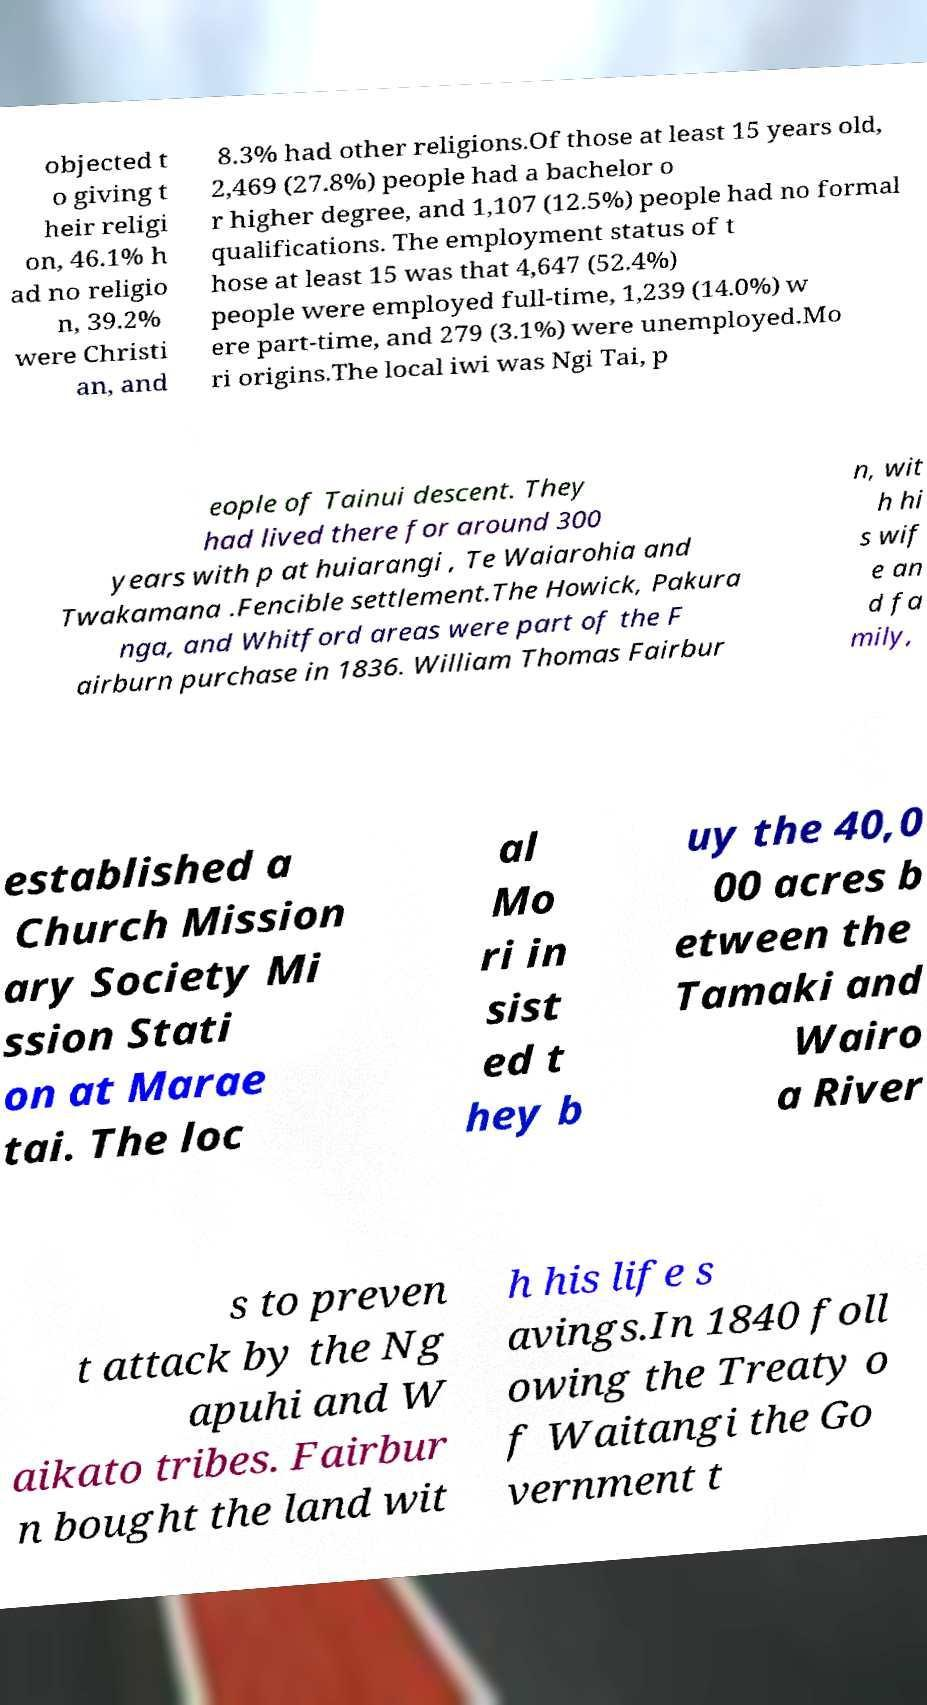Could you assist in decoding the text presented in this image and type it out clearly? objected t o giving t heir religi on, 46.1% h ad no religio n, 39.2% were Christi an, and 8.3% had other religions.Of those at least 15 years old, 2,469 (27.8%) people had a bachelor o r higher degree, and 1,107 (12.5%) people had no formal qualifications. The employment status of t hose at least 15 was that 4,647 (52.4%) people were employed full-time, 1,239 (14.0%) w ere part-time, and 279 (3.1%) were unemployed.Mo ri origins.The local iwi was Ngi Tai, p eople of Tainui descent. They had lived there for around 300 years with p at huiarangi , Te Waiarohia and Twakamana .Fencible settlement.The Howick, Pakura nga, and Whitford areas were part of the F airburn purchase in 1836. William Thomas Fairbur n, wit h hi s wif e an d fa mily, established a Church Mission ary Society Mi ssion Stati on at Marae tai. The loc al Mo ri in sist ed t hey b uy the 40,0 00 acres b etween the Tamaki and Wairo a River s to preven t attack by the Ng apuhi and W aikato tribes. Fairbur n bought the land wit h his life s avings.In 1840 foll owing the Treaty o f Waitangi the Go vernment t 